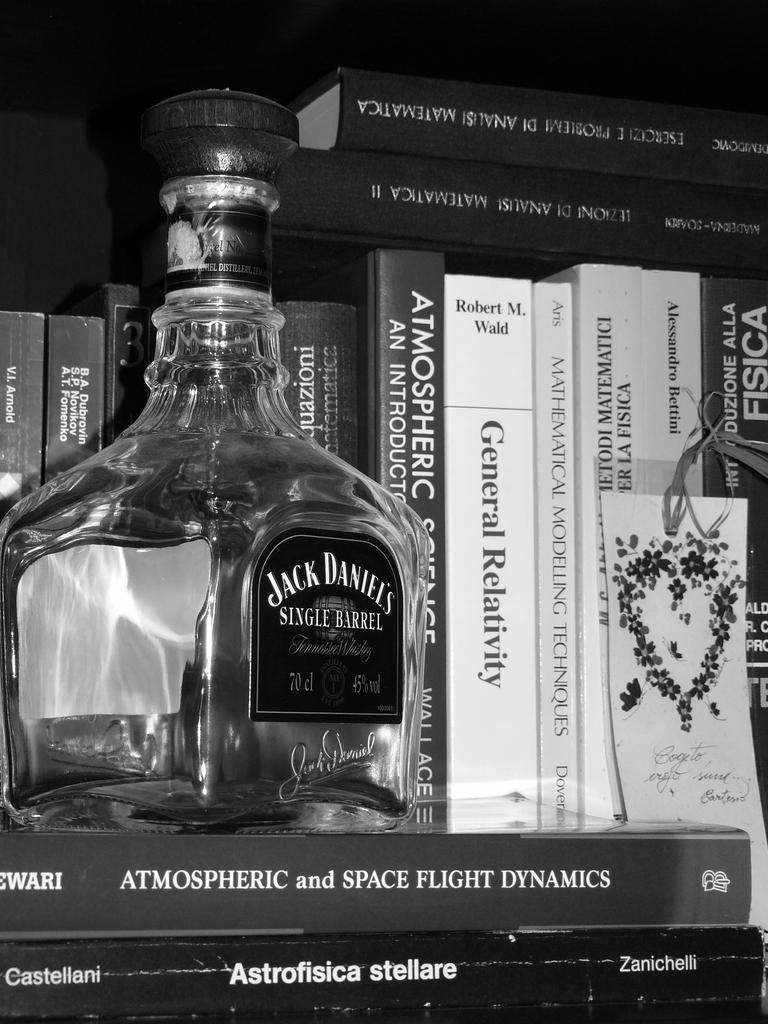What is the color scheme of the image? The image is black and white. What objects can be seen in the image? There are books and a bottle with a sticker in the image. Where is the bottle with the sticker located in relation to the books? The bottle with the sticker is above the books. What type of seed is growing in the oven in the image? There is no oven or seed present in the image; it only features books and a bottle with a sticker. 